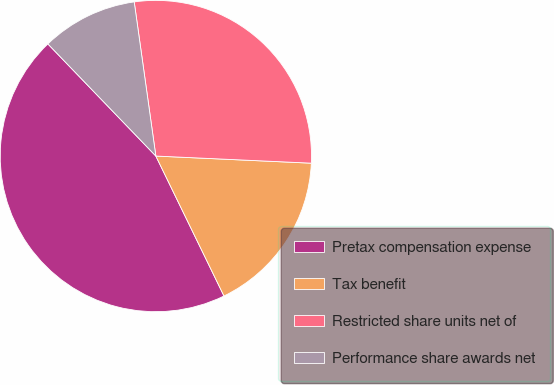Convert chart to OTSL. <chart><loc_0><loc_0><loc_500><loc_500><pie_chart><fcel>Pretax compensation expense<fcel>Tax benefit<fcel>Restricted share units net of<fcel>Performance share awards net<nl><fcel>45.01%<fcel>17.06%<fcel>27.95%<fcel>9.98%<nl></chart> 